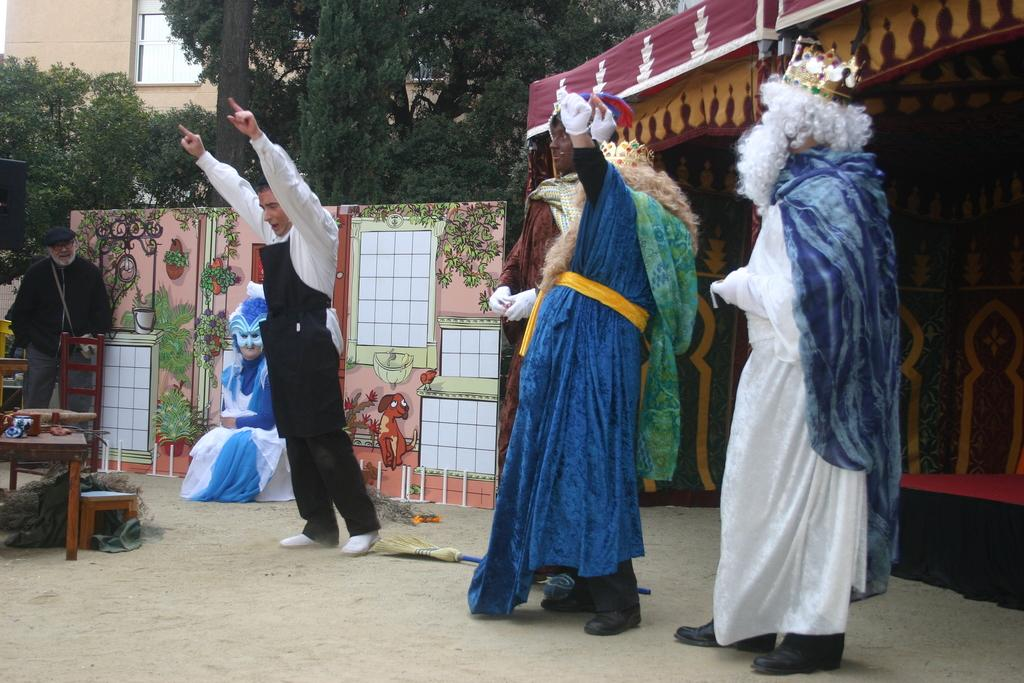How many people are in the image? There are five persons in the image. What are the persons wearing? The persons are wearing fancy dresses. What structure can be seen in the image? There is a tent in the image. What type of board is present in the image? There is an animated board in the image. What furniture can be seen in the image? There is a table and a chair in the image. What type of natural environment is visible in the image? There are trees in the image. What type of man-made structure is visible in the image? There is a building in the image. What type of nut is being used to brush the person's hair in the image? There is no nut or hairbrushing activity present in the image. What is the tendency of the persons in the image to move towards the building? The image does not show any movement or tendency of the persons towards the building. 